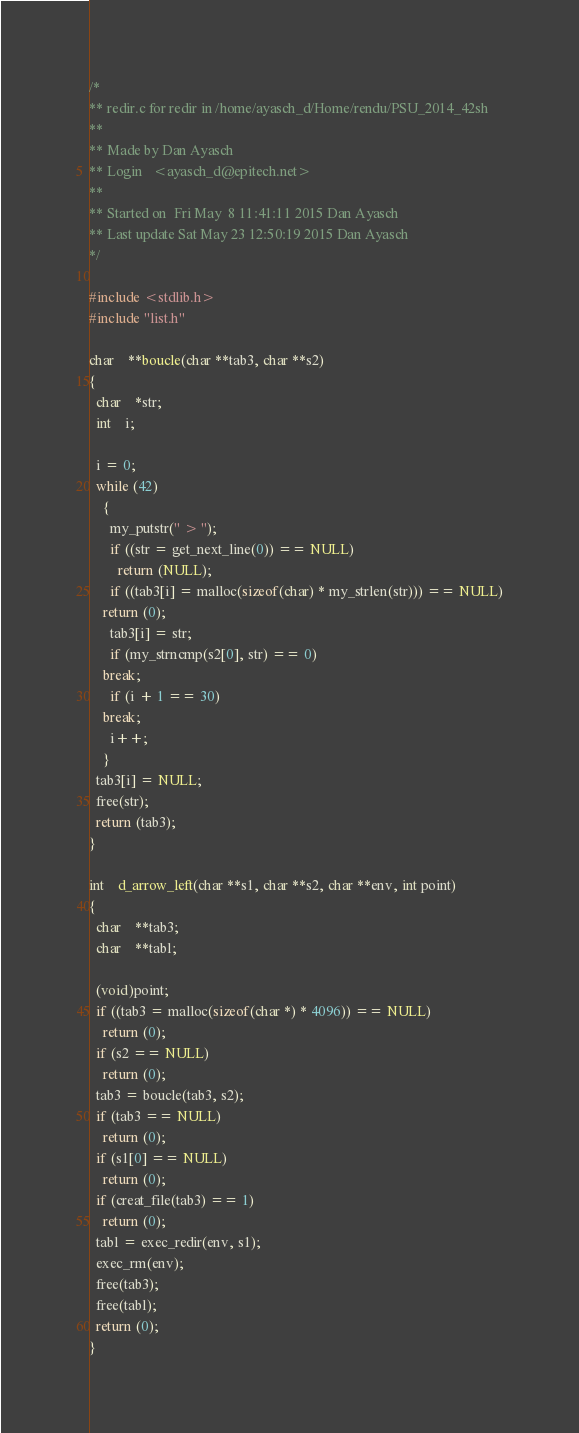Convert code to text. <code><loc_0><loc_0><loc_500><loc_500><_C_>/*
** redir.c for redir in /home/ayasch_d/Home/rendu/PSU_2014_42sh
** 
** Made by Dan Ayasch
** Login   <ayasch_d@epitech.net>
** 
** Started on  Fri May  8 11:41:11 2015 Dan Ayasch
** Last update Sat May 23 12:50:19 2015 Dan Ayasch
*/

#include <stdlib.h>
#include "list.h"

char	**boucle(char **tab3, char **s2)
{
  char	*str;
  int	i;

  i = 0;
  while (42)
    {
      my_putstr(" > ");
      if ((str = get_next_line(0)) == NULL)
        return (NULL);
      if ((tab3[i] = malloc(sizeof(char) * my_strlen(str))) == NULL)
	return (0);
      tab3[i] = str;
      if (my_strncmp(s2[0], str) == 0)
	break;
      if (i + 1 == 30)
	break;
      i++;
    }
  tab3[i] = NULL;
  free(str);
  return (tab3);
}

int	d_arrow_left(char **s1, char **s2, char **env, int point)
{
  char	**tab3;
  char	**tabl;

  (void)point;
  if ((tab3 = malloc(sizeof(char *) * 4096)) == NULL)
    return (0);
  if (s2 == NULL)
    return (0);
  tab3 = boucle(tab3, s2);
  if (tab3 == NULL)
    return (0);
  if (s1[0] == NULL)
    return (0);
  if (creat_file(tab3) == 1)
    return (0);
  tabl = exec_redir(env, s1);
  exec_rm(env);
  free(tab3);
  free(tabl);
  return (0);
}
</code> 